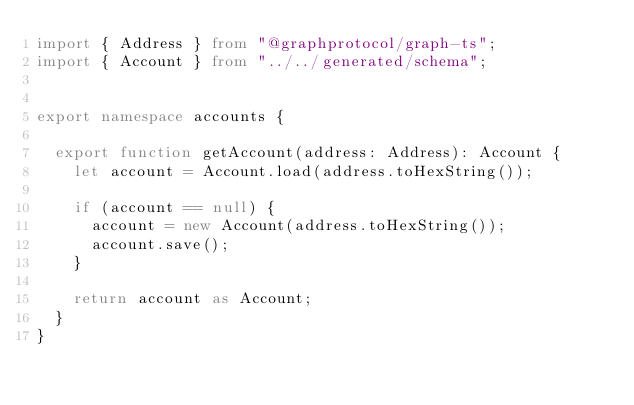<code> <loc_0><loc_0><loc_500><loc_500><_TypeScript_>import { Address } from "@graphprotocol/graph-ts";
import { Account } from "../../generated/schema";


export namespace accounts {

  export function getAccount(address: Address): Account {
    let account = Account.load(address.toHexString());

    if (account == null) {
      account = new Account(address.toHexString());
      account.save();
    }

    return account as Account;
  }
}</code> 